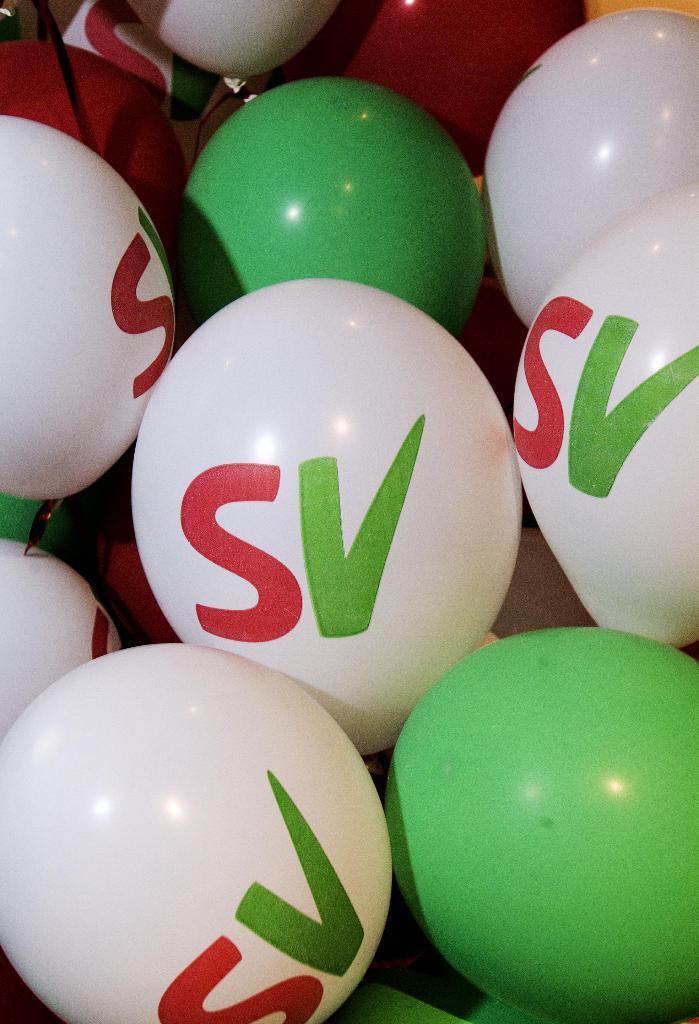In one or two sentences, can you explain what this image depicts? In the image we can see there are many balloons, white and green in color. On the balloon, there is a text. 